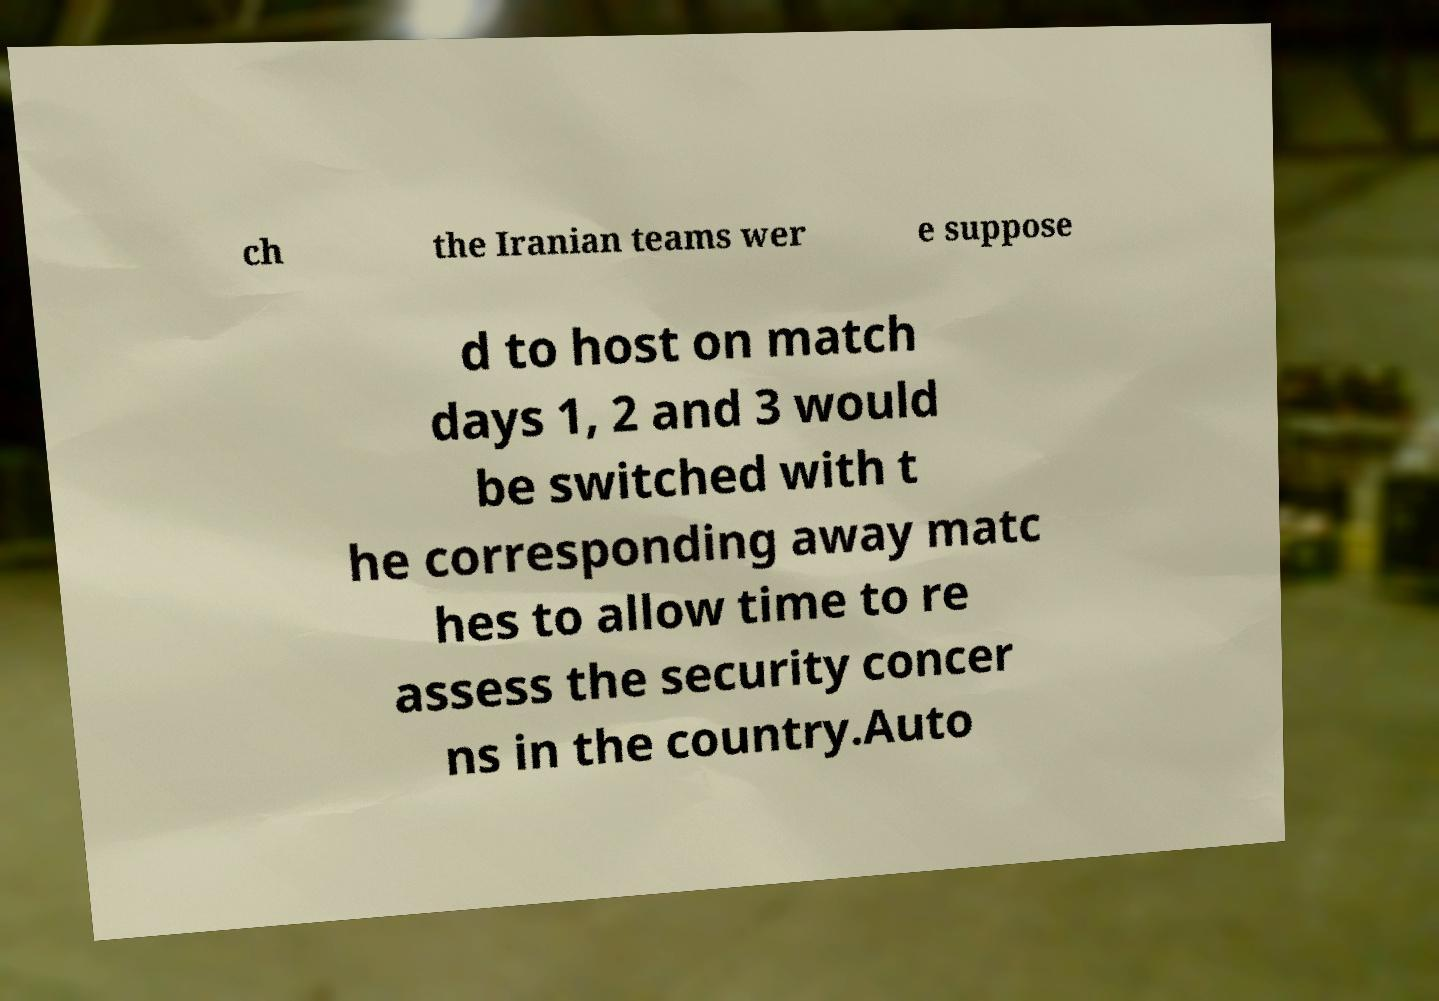Please read and relay the text visible in this image. What does it say? ch the Iranian teams wer e suppose d to host on match days 1, 2 and 3 would be switched with t he corresponding away matc hes to allow time to re assess the security concer ns in the country.Auto 